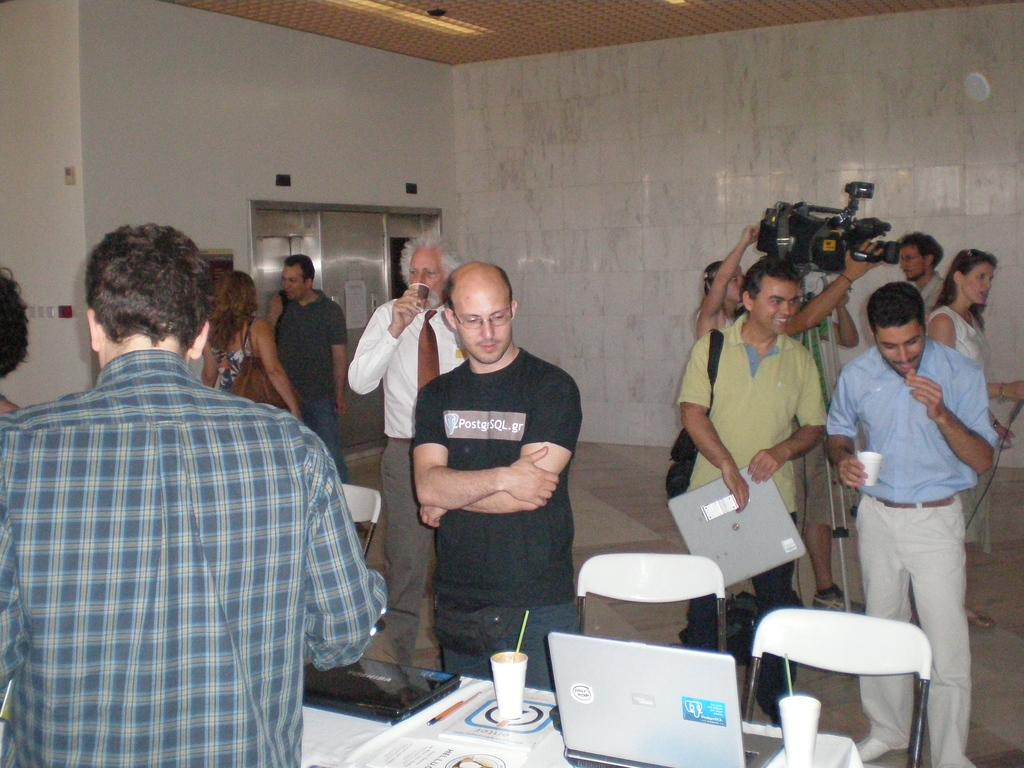What are the people in the image doing? The people are standing on the floor. What can be seen on the table in the image? There is a laptop, a glass, and papers on the table. Who is holding a camera in the image? A person is holding a camera. What is the background of the image? There is a white wall in the background. What type of fruit is being used as a cause for the people's laughter in the image? There is no fruit present in the image, nor is there any indication of laughter or a cause for laughter. What type of dress is the person wearing who is holding the camera? The person holding the camera is not described as wearing any specific type of dress in the image. 